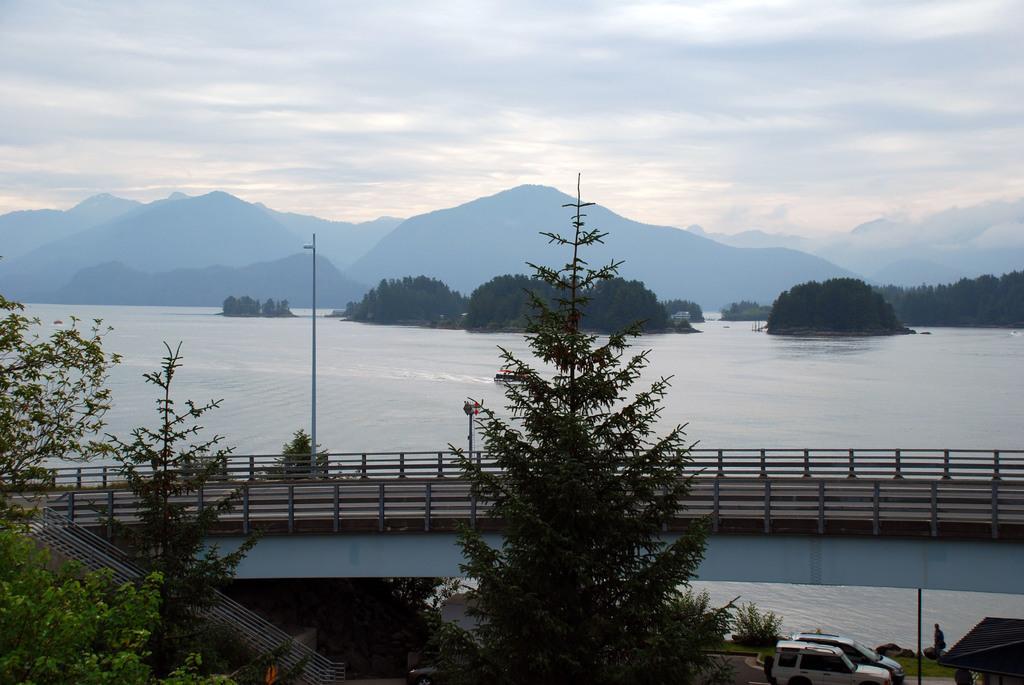Can you describe this image briefly? In this image I can see trees,bridge,vehicles,mountains and water. The sky is in white and blue color. 